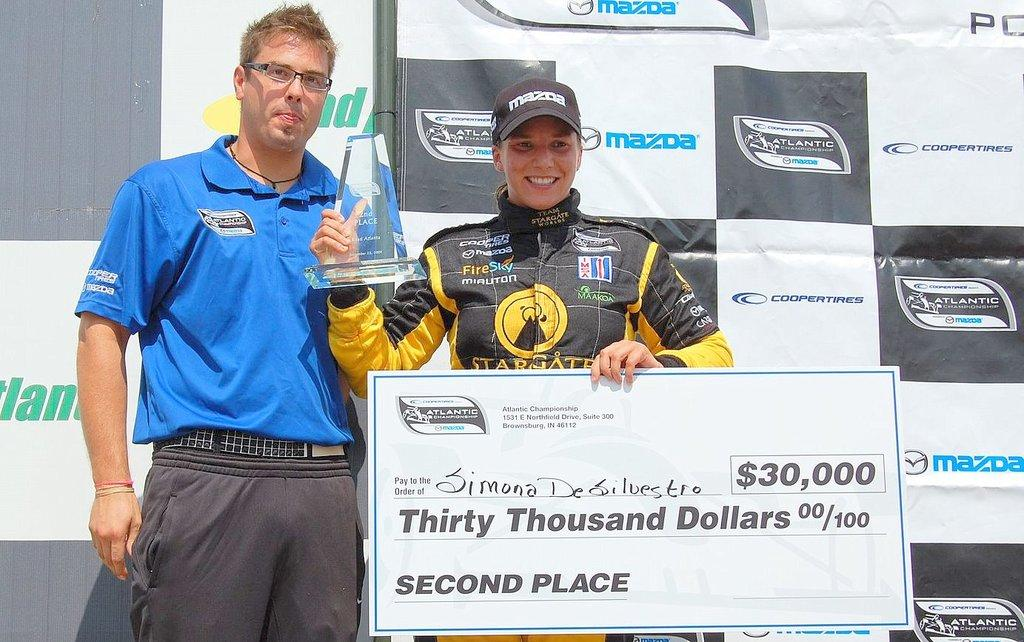<image>
Create a compact narrative representing the image presented. Woman holding a giant check which says Thirty Thousand Dollars on it. 